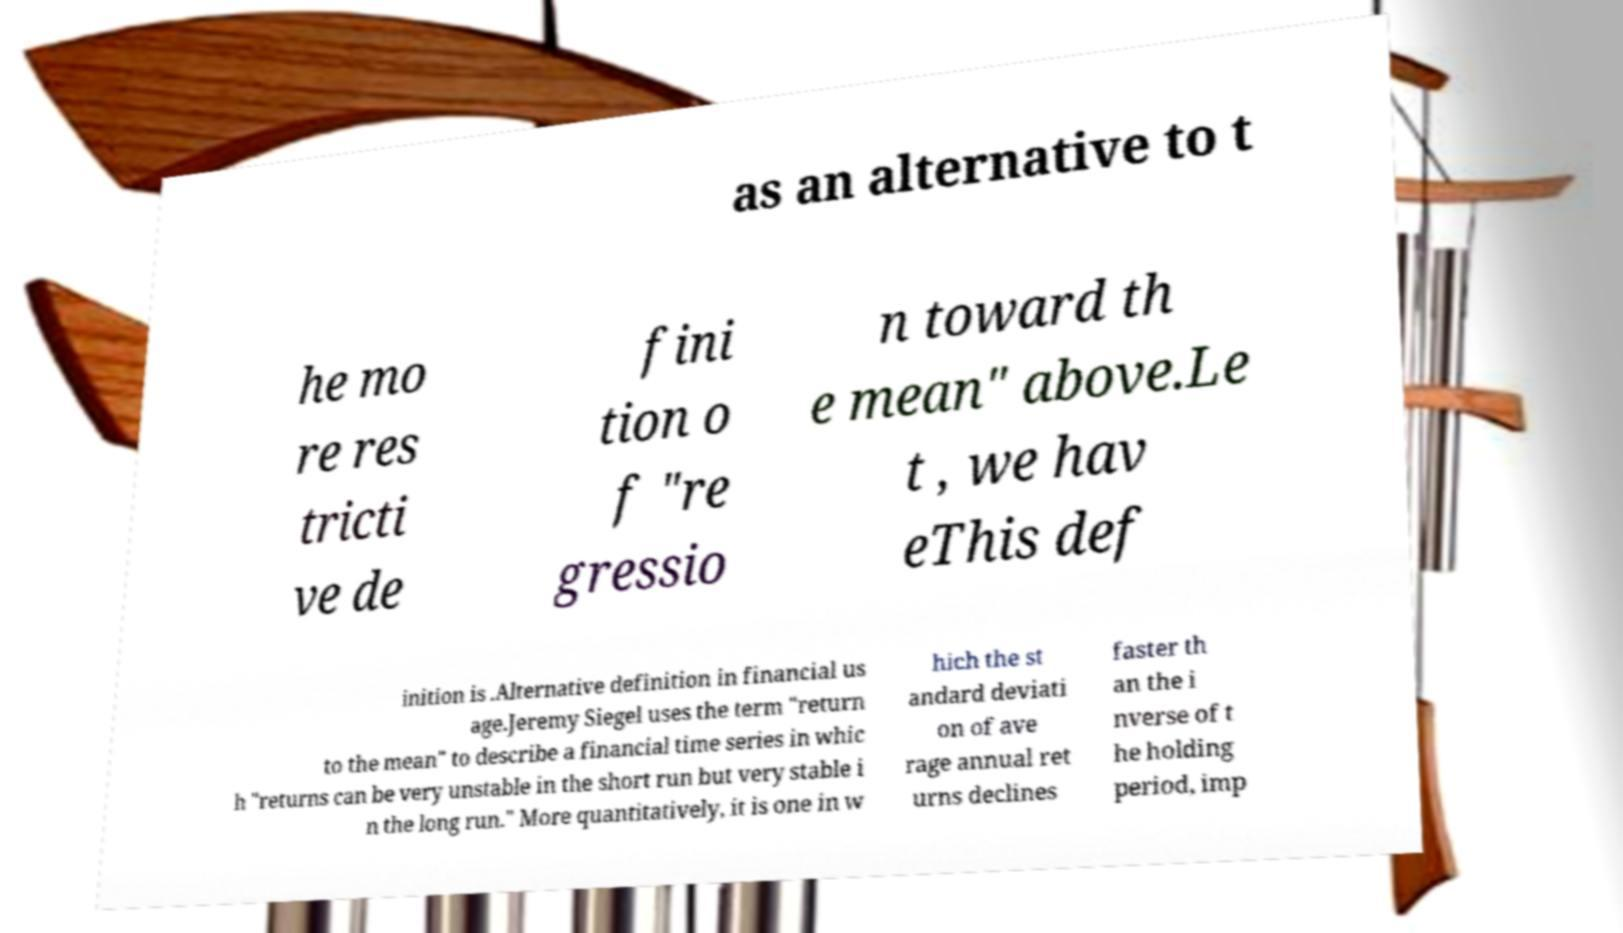There's text embedded in this image that I need extracted. Can you transcribe it verbatim? as an alternative to t he mo re res tricti ve de fini tion o f "re gressio n toward th e mean" above.Le t , we hav eThis def inition is .Alternative definition in financial us age.Jeremy Siegel uses the term "return to the mean" to describe a financial time series in whic h "returns can be very unstable in the short run but very stable i n the long run." More quantitatively, it is one in w hich the st andard deviati on of ave rage annual ret urns declines faster th an the i nverse of t he holding period, imp 